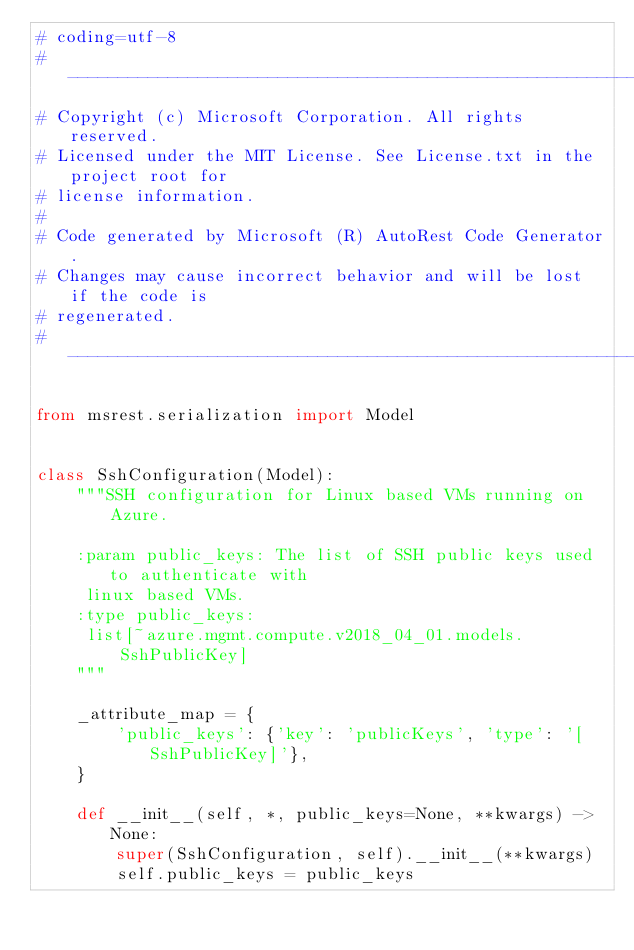Convert code to text. <code><loc_0><loc_0><loc_500><loc_500><_Python_># coding=utf-8
# --------------------------------------------------------------------------
# Copyright (c) Microsoft Corporation. All rights reserved.
# Licensed under the MIT License. See License.txt in the project root for
# license information.
#
# Code generated by Microsoft (R) AutoRest Code Generator.
# Changes may cause incorrect behavior and will be lost if the code is
# regenerated.
# --------------------------------------------------------------------------

from msrest.serialization import Model


class SshConfiguration(Model):
    """SSH configuration for Linux based VMs running on Azure.

    :param public_keys: The list of SSH public keys used to authenticate with
     linux based VMs.
    :type public_keys:
     list[~azure.mgmt.compute.v2018_04_01.models.SshPublicKey]
    """

    _attribute_map = {
        'public_keys': {'key': 'publicKeys', 'type': '[SshPublicKey]'},
    }

    def __init__(self, *, public_keys=None, **kwargs) -> None:
        super(SshConfiguration, self).__init__(**kwargs)
        self.public_keys = public_keys
</code> 